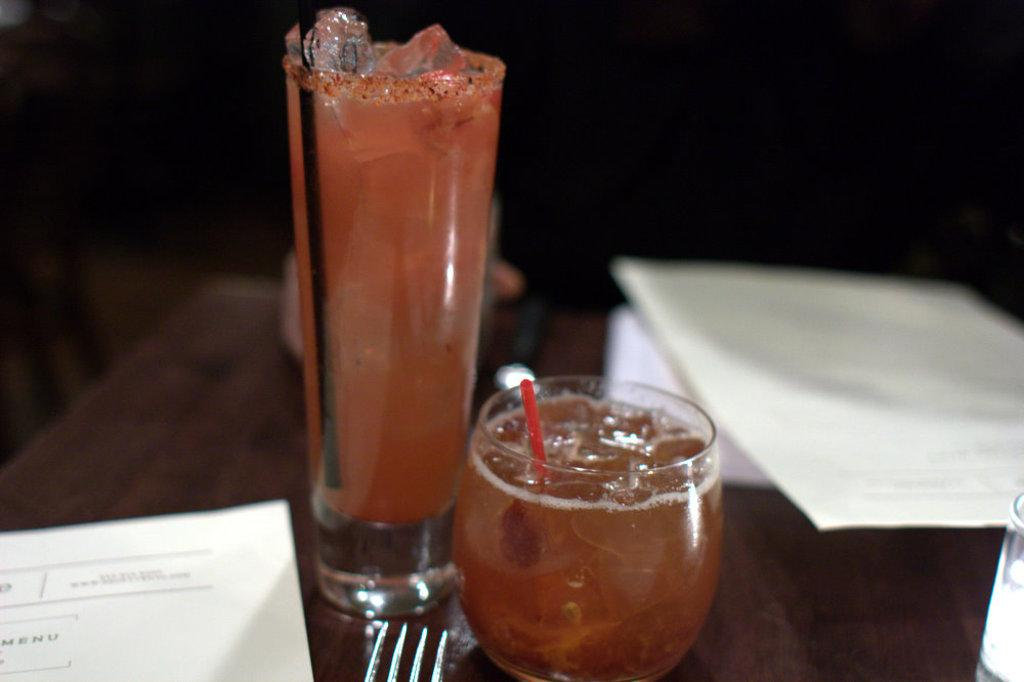What piece of furniture is present in the image? There is a table in the image. What items are placed on the table? There are papers, glasses, and forks on the table. What type of animal can be seen interacting with the papers on the table? There is no animal present in the image; it only features a table with papers, glasses, and forks. 